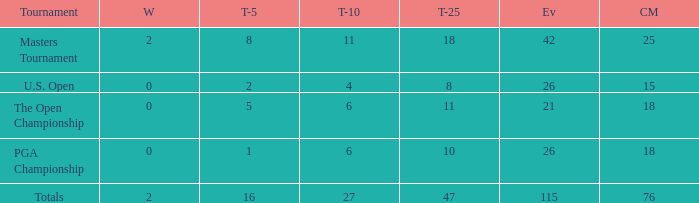How many wins are there in total when 76 cuts are made and more than 115 events occur? None. 